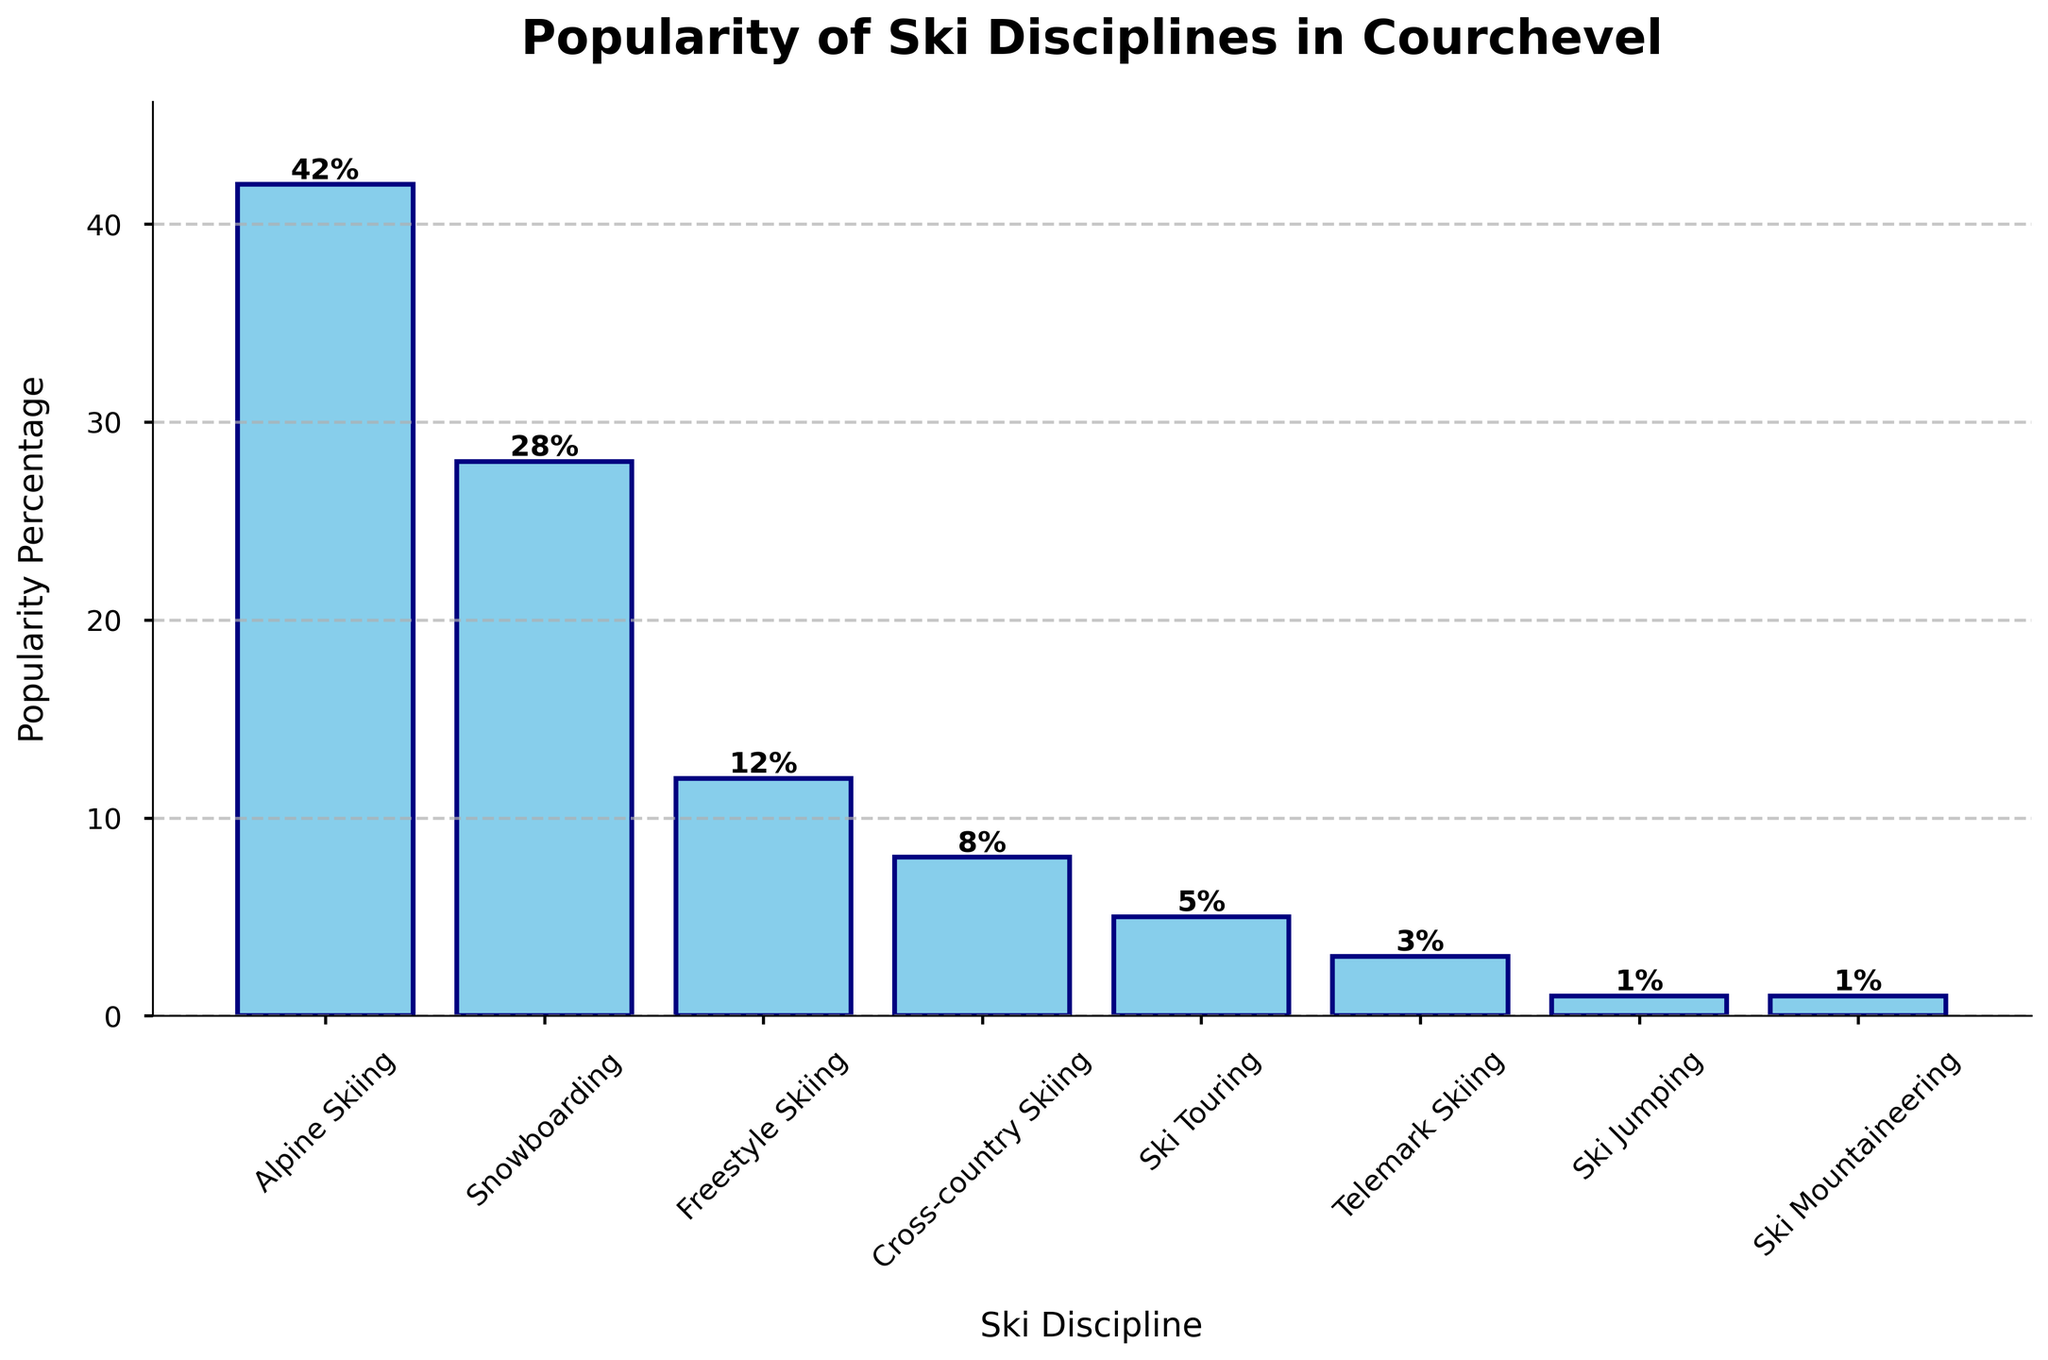What is the most popular ski discipline among tourists in Courchevel? By looking at the heights of the bars, the tallest bar represents Alpine Skiing at 42%. Hence, Alpine Skiing is the most popular ski discipline.
Answer: Alpine Skiing Which ski discipline is the least popular among tourists in Courchevel? The shortest bars belong to Ski Jumping and Ski Mountaineering, both at 1%. Thus, these two disciplines are the least popular.
Answer: Ski Jumping and Ski Mountaineering What is the combined popularity percentage of Snowboarding and Freestyle Skiing? The percentage for Snowboarding is 28% and for Freestyle Skiing is 12%. Adding them together gives 28% + 12% = 40%.
Answer: 40% How much more popular is Alpine Skiing than Cross-country Skiing? Alpine Skiing has a popularity of 42% and Cross-country Skiing has 8%. The difference is 42% - 8% = 34%.
Answer: 34% Which ski discipline has a popularity rate exactly one-third of Alpine Skiing? Alpine Skiing is at 42%. One-third of 42% is 42% / 3 = 14%. None matches exactly, but Freestyle Skiing at 12% is the closest.
Answer: None, closest is Freestyle Skiing at 12% What is the average popularity percentage of all ski disciplines? Adding the popularity percentages (42 + 28 + 12 + 8 + 5 + 3 + 1 + 1 = 100) and dividing by the number of disciplines (8) gives 100 / 8 = 12.5%.
Answer: 12.5% Is Telemark Skiing more or less popular than Ski Touring? Telemark Skiing has a popularity of 3%, whereas Ski Touring has 5%. Hence, Telemark Skiing is less popular than Ski Touring.
Answer: Less How many ski disciplines have a popularity percentage above 10%? The disciplines above 10% are Alpine Skiing (42%), Snowboarding (28%), and Freestyle Skiing (12%). There are 3 disciplines.
Answer: 3 What is the difference in popularity between the two least popular disciplines and Snowboarding? The least popular disciplines are Ski Jumping and Ski Mountaineering at 1% each, total is 2%. Snowboarding is at 28%. The difference is 28% - 2% = 26%.
Answer: 26% By how much does the combined popularity of Ski Touring and Telemark Skiing fall short of Snowboarding? Ski Touring is at 5% and Telemark Skiing at 3%, combined 5% + 3% = 8%. Snowboarding is at 28%. The shortfall is 28% - 8% = 20%.
Answer: 20% 